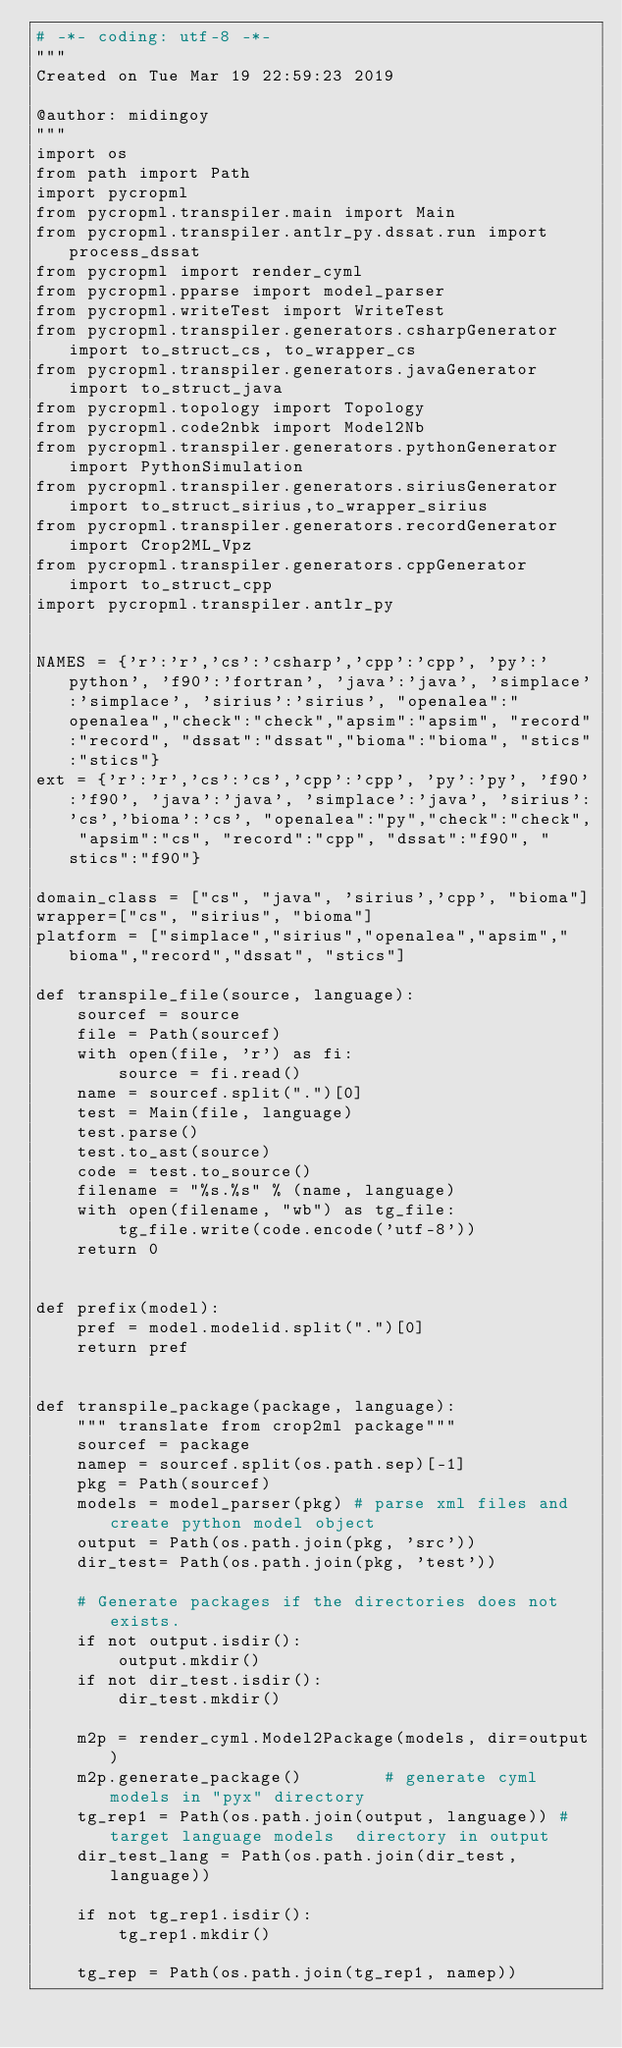<code> <loc_0><loc_0><loc_500><loc_500><_Python_># -*- coding: utf-8 -*-
"""
Created on Tue Mar 19 22:59:23 2019

@author: midingoy
"""
import os
from path import Path
import pycropml
from pycropml.transpiler.main import Main
from pycropml.transpiler.antlr_py.dssat.run import process_dssat
from pycropml import render_cyml
from pycropml.pparse import model_parser
from pycropml.writeTest import WriteTest
from pycropml.transpiler.generators.csharpGenerator import to_struct_cs, to_wrapper_cs
from pycropml.transpiler.generators.javaGenerator import to_struct_java
from pycropml.topology import Topology
from pycropml.code2nbk import Model2Nb
from pycropml.transpiler.generators.pythonGenerator import PythonSimulation
from pycropml.transpiler.generators.siriusGenerator import to_struct_sirius,to_wrapper_sirius
from pycropml.transpiler.generators.recordGenerator import Crop2ML_Vpz
from pycropml.transpiler.generators.cppGenerator import to_struct_cpp
import pycropml.transpiler.antlr_py 


NAMES = {'r':'r','cs':'csharp','cpp':'cpp', 'py':'python', 'f90':'fortran', 'java':'java', 'simplace':'simplace', 'sirius':'sirius', "openalea":"openalea","check":"check","apsim":"apsim", "record":"record", "dssat":"dssat","bioma":"bioma", "stics":"stics"}
ext = {'r':'r','cs':'cs','cpp':'cpp', 'py':'py', 'f90':'f90', 'java':'java', 'simplace':'java', 'sirius':'cs','bioma':'cs', "openalea":"py","check":"check", "apsim":"cs", "record":"cpp", "dssat":"f90", "stics":"f90"}

domain_class = ["cs", "java", 'sirius','cpp', "bioma"]
wrapper=["cs", "sirius", "bioma"]
platform = ["simplace","sirius","openalea","apsim","bioma","record","dssat", "stics"]

def transpile_file(source, language):
    sourcef = source
    file = Path(sourcef)
    with open(file, 'r') as fi:
        source = fi.read()
    name = sourcef.split(".")[0]
    test = Main(file, language)
    test.parse()
    test.to_ast(source)
    code = test.to_source()
    filename = "%s.%s" % (name, language)
    with open(filename, "wb") as tg_file:
        tg_file.write(code.encode('utf-8'))
    return 0


def prefix(model):
    pref = model.modelid.split(".")[0]
    return pref


def transpile_package(package, language):
    """ translate from crop2ml package"""
    sourcef = package
    namep = sourcef.split(os.path.sep)[-1]
    pkg = Path(sourcef)
    models = model_parser(pkg) # parse xml files and create python model object
    output = Path(os.path.join(pkg, 'src'))
    dir_test= Path(os.path.join(pkg, 'test'))

    # Generate packages if the directories does not exists.
    if not output.isdir():
        output.mkdir()
    if not dir_test.isdir():
        dir_test.mkdir()

    m2p = render_cyml.Model2Package(models, dir=output)
    m2p.generate_package()        # generate cyml models in "pyx" directory
    tg_rep1 = Path(os.path.join(output, language)) # target language models  directory in output
    dir_test_lang = Path(os.path.join(dir_test, language))
    
    if not tg_rep1.isdir():
        tg_rep1.mkdir()
        
    tg_rep = Path(os.path.join(tg_rep1, namep))</code> 